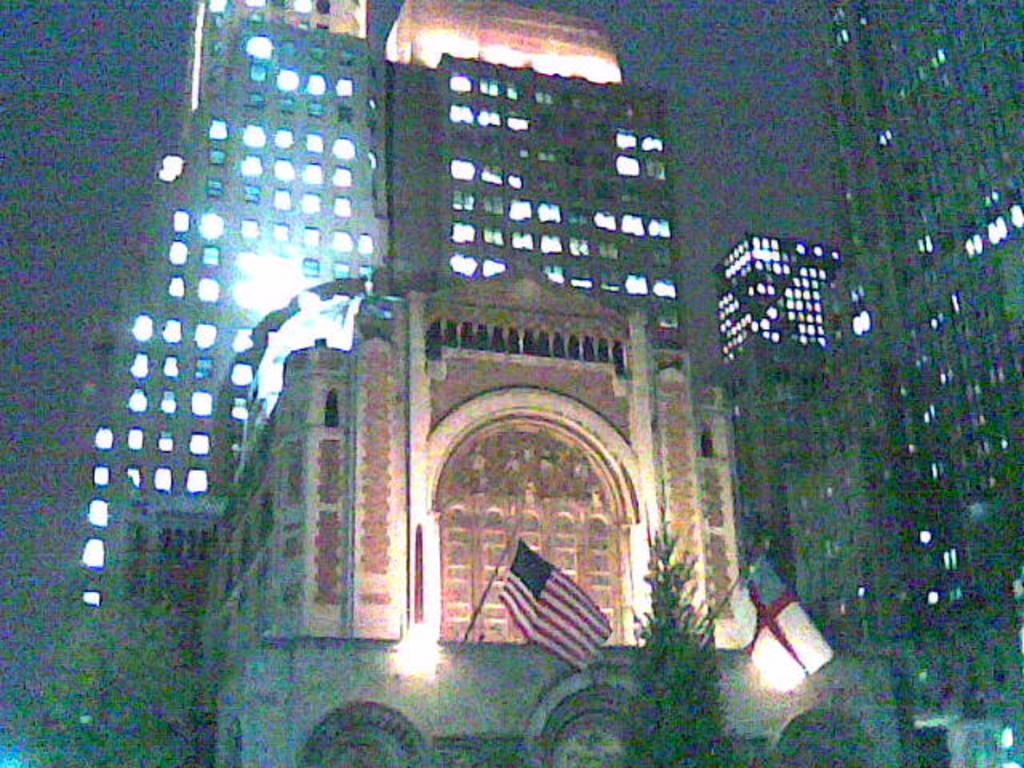What type of structures are visible in the image? There are buildings with walls in the image. What feature do the buildings have? The buildings have lights. What type of vegetation is present in the image? There is a tree at the bottom of the image. What additional objects can be seen in the image? There are flags with poles in the image. Where are the girls playing in the image? There are no girls present in the image. What type of sweater is draped over the cemetery in the image? There is no sweater or cemetery present in the image. 